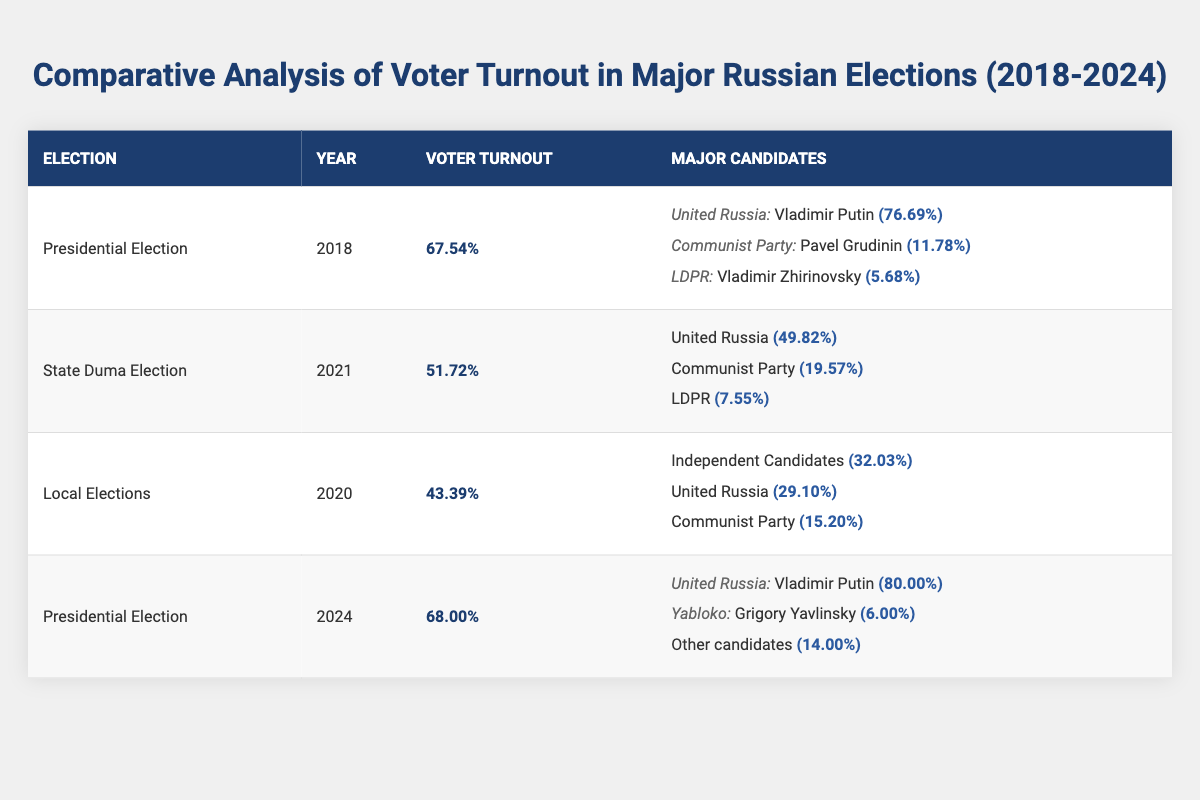What was the voter turnout percentage in the 2021 State Duma Election? The table indicates that the voter turnout percentage for the 2021 State Duma Election is listed explicitly as 51.72%.
Answer: 51.72% Which major candidate received the highest vote share in the 2018 Presidential Election? In the table, under the 2018 Presidential Election, it shows Vladimir Putin from the United Russia party received the highest vote share of 76.69%.
Answer: Vladimir Putin What was the difference in voter turnout between the 2018 Presidential Election and the 2020 Local Elections? The voter turnout for the 2018 Presidential Election was 67.54% and for the 2020 Local Elections it was 43.39%. The difference is calculated as 67.54% - 43.39% = 24.15%.
Answer: 24.15% Did any candidate in the 2024 Presidential Election receive a vote share of less than 7%? According to the table, Grigory Yavlinsky received a vote share of 6.00%, which is less than 7%. Therefore, the answer is yes.
Answer: Yes What was the average voter turnout across all elections listed in the table? To find the average voter turnout, I sum the voter turnout percentages: (67.54 + 51.72 + 43.39 + 68.00) ÷ 4 = 57.65%.
Answer: 57.65% In which year did the highest voter turnout occur, and what was the percentage? From the data, the 2018 Presidential Election had the highest voter turnout of 67.54%.
Answer: 2018, 67.54% Was the voter turnout in the 2021 State Duma Election higher than in the 2020 Local Elections? The voter turnout for the 2021 State Duma Election is 51.72%, whereas the 2020 Local Elections had a turnout of 43.39%. Since 51.72% is greater than 43.39%, the answer is yes.
Answer: Yes What percentage of vote share did the Communist Party receive in the 2021 State Duma Election? The table lists the vote share for the Communist Party in the 2021 State Duma Election as 19.57%.
Answer: 19.57% What factors contributed to the increase in voter turnout from the 2021 Duma Election to the 2024 Presidential Election? To analyze, the 2021 Duma Election had a turnout of 51.72% and the 2024 Presidential Election has a turnout of 68.00%. This indicates an increase, potentially due to heightened public interest, campaign effectiveness, or significant political events leading up to the 2024 election.
Answer: Increased interest/engagement How many votes did Independent Candidates receive in the 2020 Local Elections compared to United Russia's share in the same election? The Independent Candidates received a vote share of 32.03%, while United Russia received 29.10%. Therefore, the Independent Candidates received more votes than United Russia in the 2020 Local Elections.
Answer: Independent Candidates received more votes 